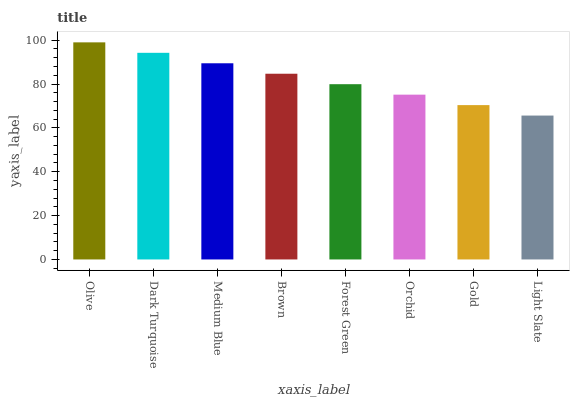Is Light Slate the minimum?
Answer yes or no. Yes. Is Olive the maximum?
Answer yes or no. Yes. Is Dark Turquoise the minimum?
Answer yes or no. No. Is Dark Turquoise the maximum?
Answer yes or no. No. Is Olive greater than Dark Turquoise?
Answer yes or no. Yes. Is Dark Turquoise less than Olive?
Answer yes or no. Yes. Is Dark Turquoise greater than Olive?
Answer yes or no. No. Is Olive less than Dark Turquoise?
Answer yes or no. No. Is Brown the high median?
Answer yes or no. Yes. Is Forest Green the low median?
Answer yes or no. Yes. Is Medium Blue the high median?
Answer yes or no. No. Is Dark Turquoise the low median?
Answer yes or no. No. 